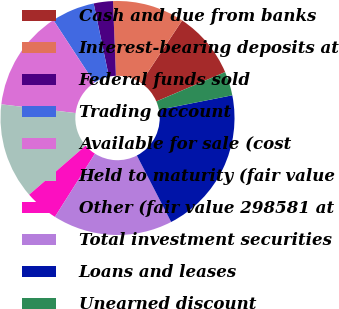Convert chart to OTSL. <chart><loc_0><loc_0><loc_500><loc_500><pie_chart><fcel>Cash and due from banks<fcel>Interest-bearing deposits at<fcel>Federal funds sold<fcel>Trading account<fcel>Available for sale (cost<fcel>Held to maturity (fair value<fcel>Other (fair value 298581 at<fcel>Total investment securities<fcel>Loans and leases<fcel>Unearned discount<nl><fcel>9.27%<fcel>9.93%<fcel>2.65%<fcel>5.96%<fcel>13.91%<fcel>13.24%<fcel>4.64%<fcel>16.56%<fcel>20.53%<fcel>3.31%<nl></chart> 